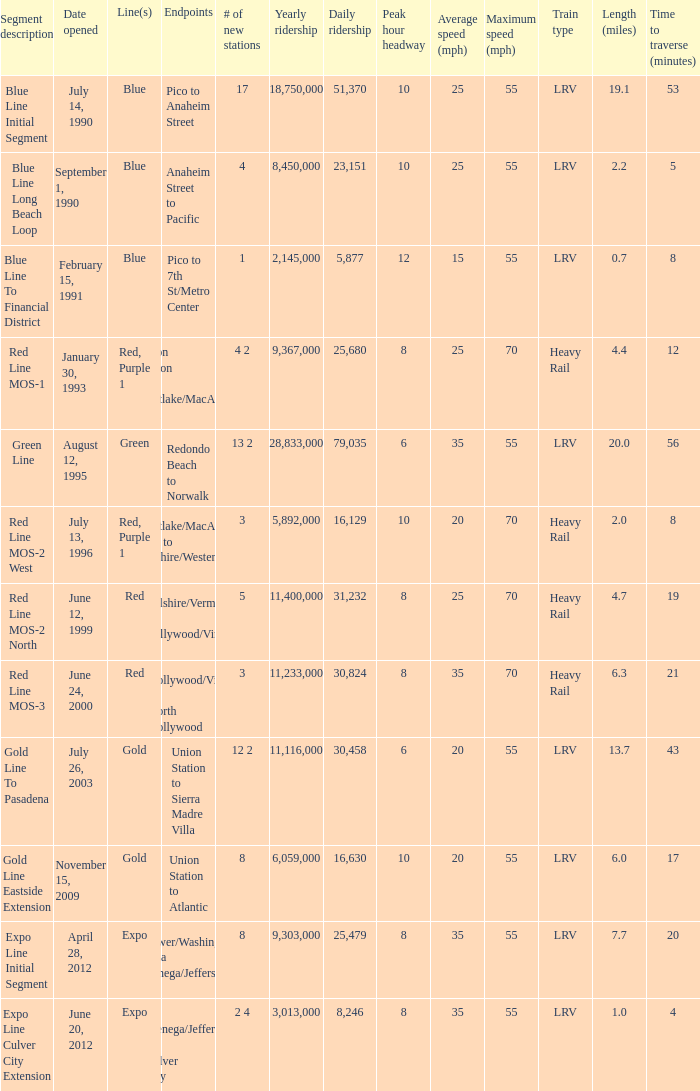Can you give me this table as a dict? {'header': ['Segment description', 'Date opened', 'Line(s)', 'Endpoints', '# of new stations', 'Yearly ridership', 'Daily ridership', 'Peak hour headway', 'Average speed (mph)', 'Maximum speed (mph)', 'Train type', 'Length (miles)', 'Time to traverse (minutes)'], 'rows': [['Blue Line Initial Segment', 'July 14, 1990', 'Blue', 'Pico to Anaheim Street', '17', '18,750,000', '51,370', '10', '25', '55', 'LRV', '19.1', '53'], ['Blue Line Long Beach Loop', 'September 1, 1990', 'Blue', 'Anaheim Street to Pacific', '4', '8,450,000', '23,151', '10', '25', '55', 'LRV', '2.2', '5'], ['Blue Line To Financial District', 'February 15, 1991', 'Blue', 'Pico to 7th St/Metro Center', '1', '2,145,000', '5,877', '12', '15', '55', 'LRV', '0.7', '8'], ['Red Line MOS-1', 'January 30, 1993', 'Red, Purple 1', 'Union Station to Westlake/MacArthur Park', '4 2', '9,367,000', '25,680', '8', '25', '70', 'Heavy Rail', '4.4', '12'], ['Green Line', 'August 12, 1995', 'Green', 'Redondo Beach to Norwalk', '13 2', '28,833,000', '79,035', '6', '35', '55', 'LRV', '20.0', '56'], ['Red Line MOS-2 West', 'July 13, 1996', 'Red, Purple 1', 'Westlake/MacArthur Park to Wilshire/Western', '3', '5,892,000', '16,129', '10', '20', '70', 'Heavy Rail', '2.0', '8'], ['Red Line MOS-2 North', 'June 12, 1999', 'Red', 'Wilshire/Vermont to Hollywood/Vine', '5', '11,400,000', '31,232', '8', '25', '70', 'Heavy Rail', '4.7', '19'], ['Red Line MOS-3', 'June 24, 2000', 'Red', 'Hollywood/Vine to North Hollywood', '3', '11,233,000', '30,824', '8', '35', '70', 'Heavy Rail', '6.3', '21'], ['Gold Line To Pasadena', 'July 26, 2003', 'Gold', 'Union Station to Sierra Madre Villa', '12 2', '11,116,000', '30,458', '6', '20', '55', 'LRV', '13.7', '43'], ['Gold Line Eastside Extension', 'November 15, 2009', 'Gold', 'Union Station to Atlantic', '8', '6,059,000', '16,630', '10', '20', '55', 'LRV', '6.0', '17'], ['Expo Line Initial Segment', 'April 28, 2012', 'Expo', 'Flower/Washington to La Cienega/Jefferson 3', '8', '9,303,000', '25,479', '8', '35', '55', 'LRV', '7.7', '20'], ['Expo Line Culver City Extension', 'June 20, 2012', 'Expo', 'La Cienega/Jefferson to Culver City', '2 4', '3,013,000', '8,246', '8', '35', '55', 'LRV', '1.0', '4']]} What date of segment description red line mos-2 north open? June 12, 1999. 